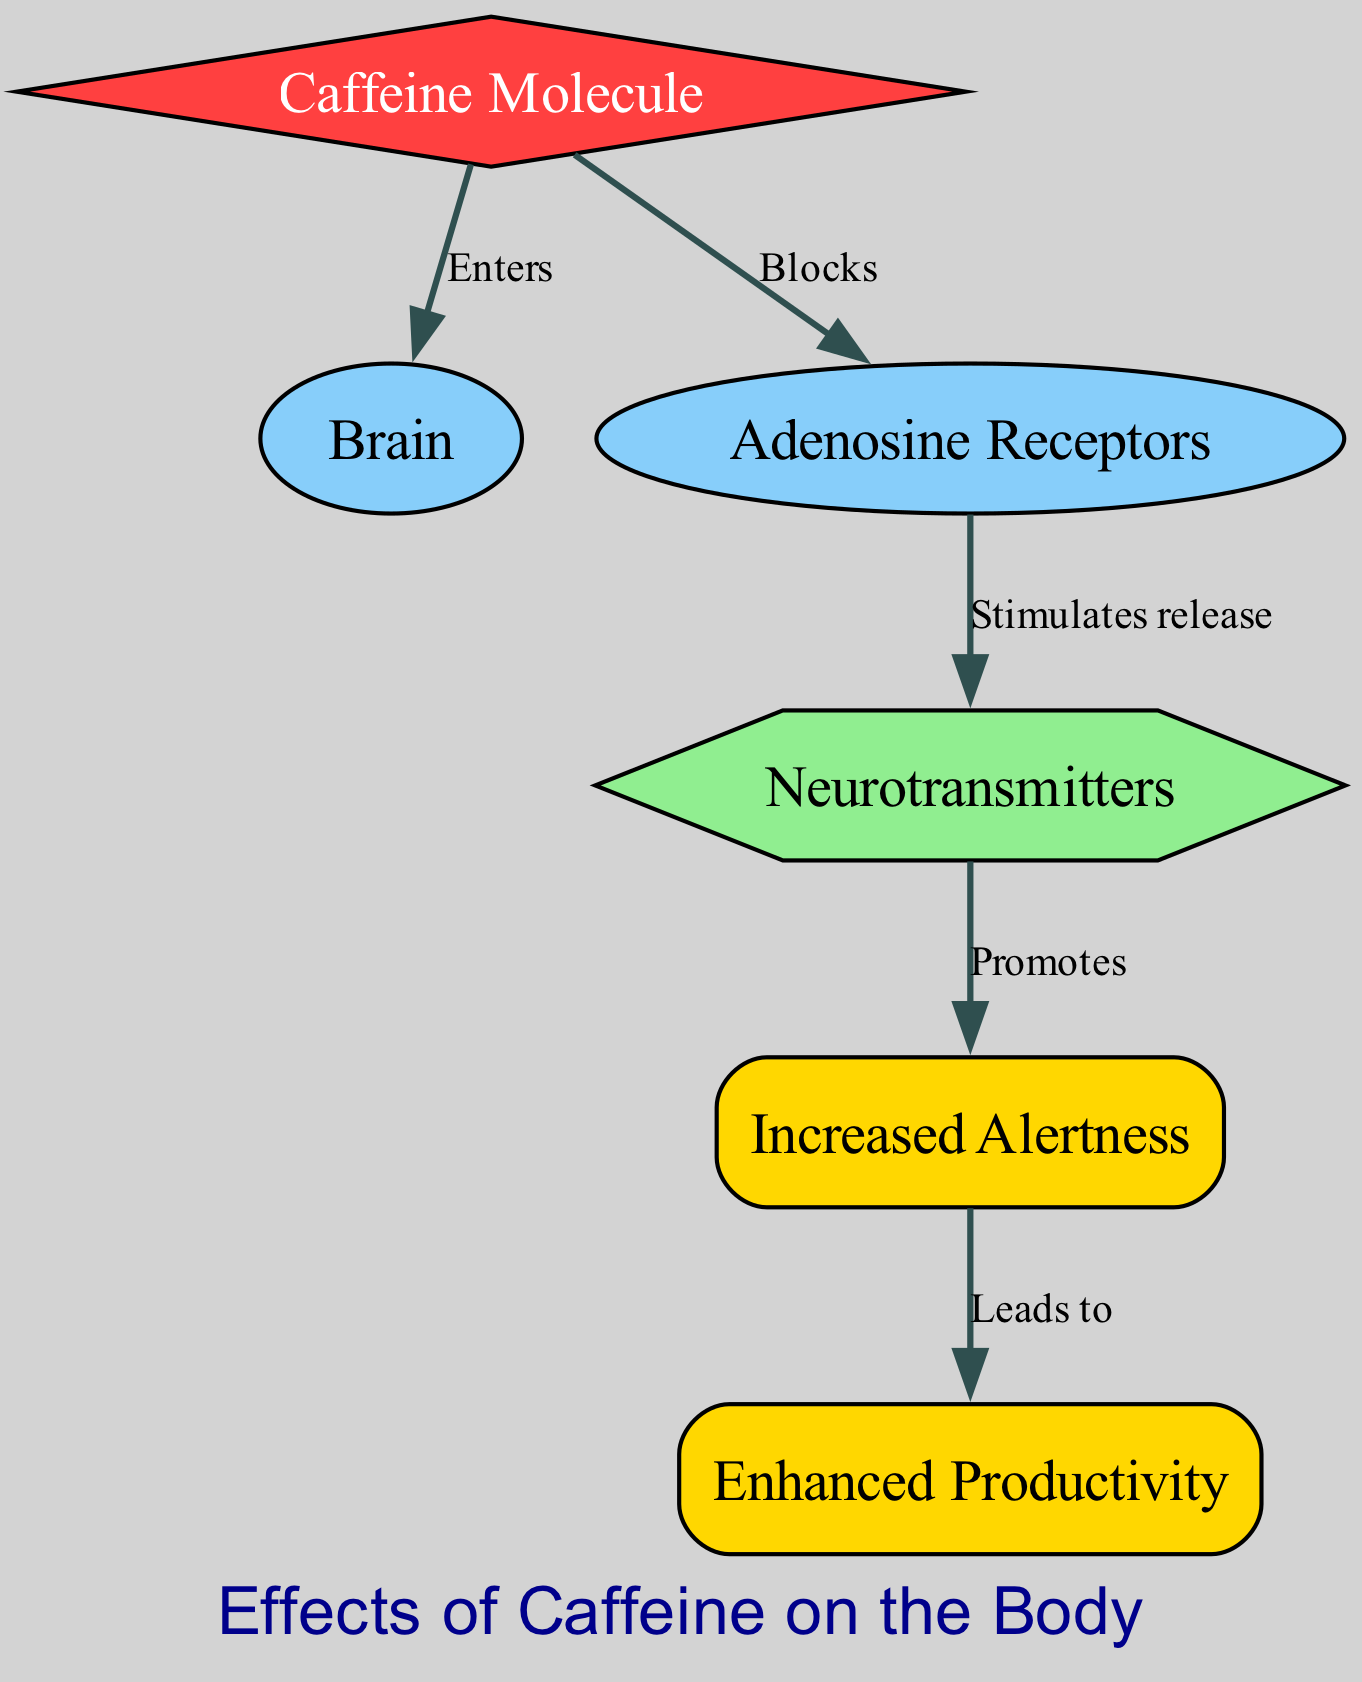What is the primary molecule highlighted in the diagram? The diagram prominently features the "Caffeine Molecule," which is represented as the main node that initiates the process.
Answer: Caffeine Molecule How many nodes are present in the diagram? The diagram includes six nodes: Caffeine Molecule, Brain, Adenosine Receptors, Neurotransmitters, Increased Alertness, and Enhanced Productivity. Counting these gives a total of six nodes.
Answer: 6 What relationship exists between caffeine and adenosine? The diagram indicates that caffeine "Blocks" adenosine, showing a direct inhibitory relationship where caffeine interferes with adenosine's effects on the brain.
Answer: Blocks What is the outcome prompted by neurotransmitters according to the diagram? Neurotransmitters "Promote" increased alertness as depicted in the diagram, showing their role in enhancing cognitive states.
Answer: Promotes How many edges connect the nodes in the diagram? There are five edges in the diagram, connecting the nodes and indicating the flow of influence; each edge represents a specific relationship between the nodes.
Answer: 5 In which process does increased alertness lead to? The diagram illustrates that increased alertness "Leads to" enhanced productivity, showing the positive outcome of the alertness induced by the process.
Answer: Leads to What shape is the caffeine molecule node? The caffeine molecule is represented in the diagram as a diamond shape, visually distinguishing it from other types of nodes.
Answer: Diamond What is the final effect of caffeine on the body as shown in the diagram? The final effect is "Enhanced Productivity," which serves as the ultimate outcome of the sequence initiated by caffeine's action through the diagram.
Answer: Enhanced Productivity 